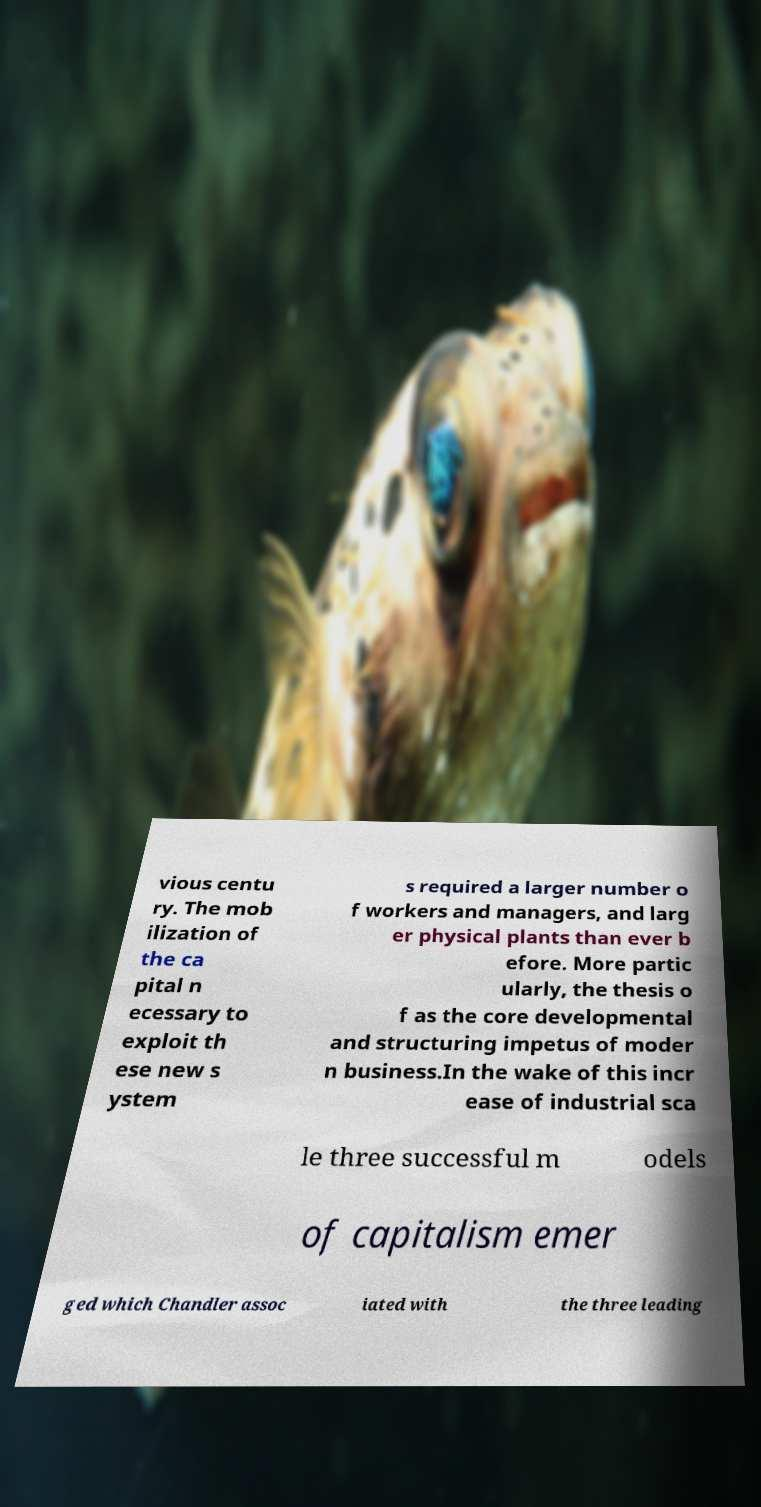Can you accurately transcribe the text from the provided image for me? vious centu ry. The mob ilization of the ca pital n ecessary to exploit th ese new s ystem s required a larger number o f workers and managers, and larg er physical plants than ever b efore. More partic ularly, the thesis o f as the core developmental and structuring impetus of moder n business.In the wake of this incr ease of industrial sca le three successful m odels of capitalism emer ged which Chandler assoc iated with the three leading 